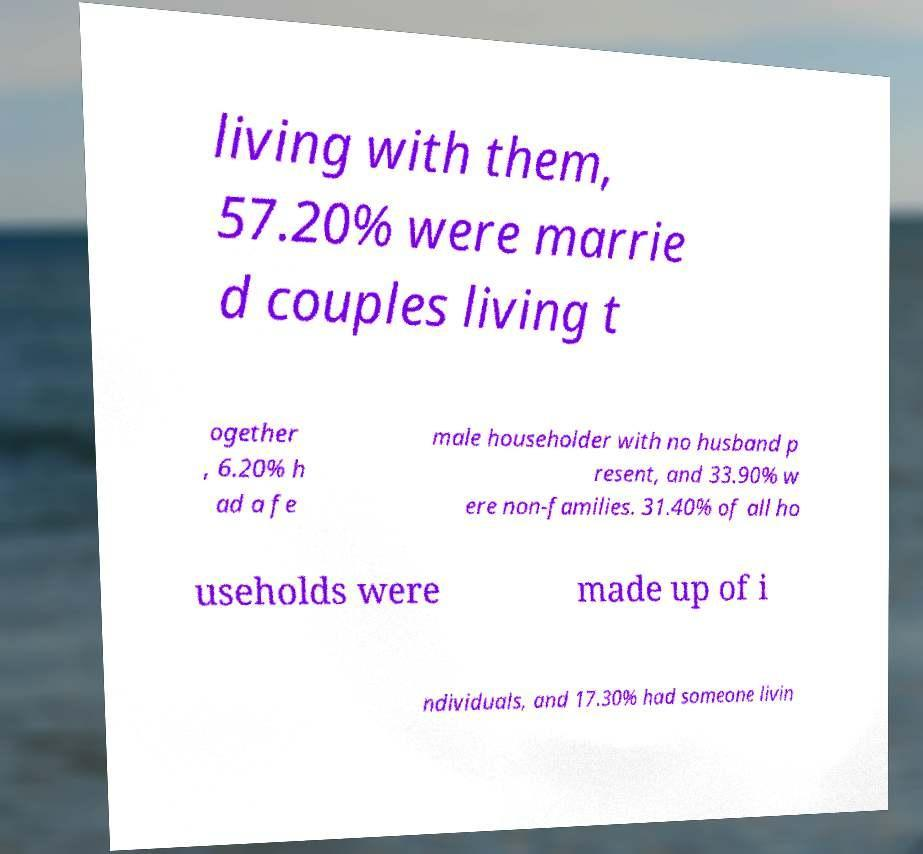For documentation purposes, I need the text within this image transcribed. Could you provide that? living with them, 57.20% were marrie d couples living t ogether , 6.20% h ad a fe male householder with no husband p resent, and 33.90% w ere non-families. 31.40% of all ho useholds were made up of i ndividuals, and 17.30% had someone livin 